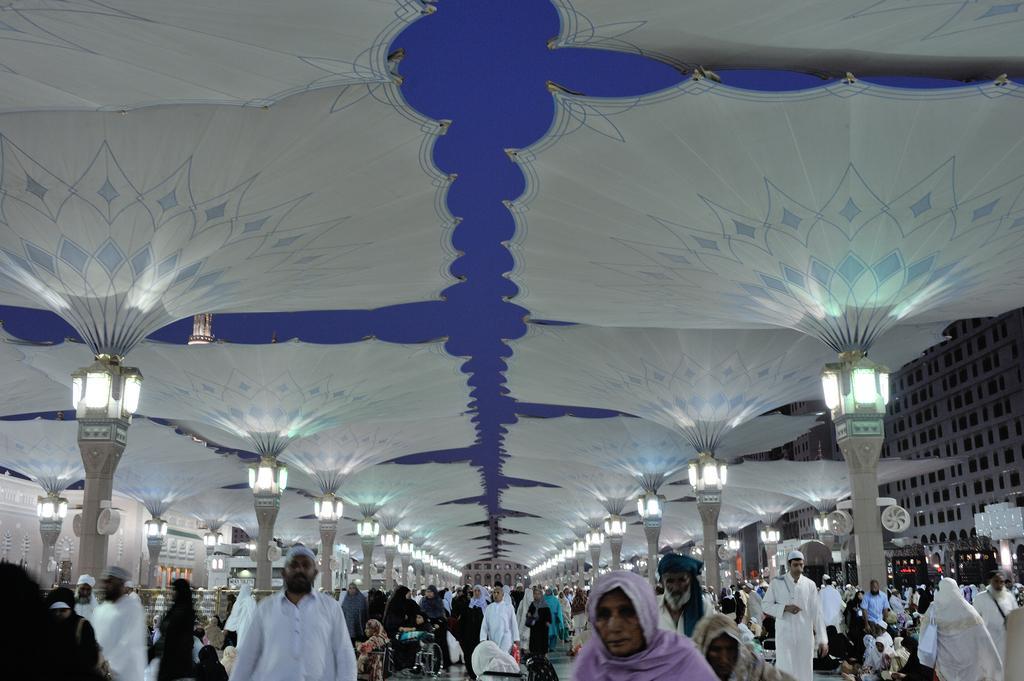Could you give a brief overview of what you see in this image? In this image, we can see people under the tents and there are lights. In the background, we can see vehicles and buildings. 